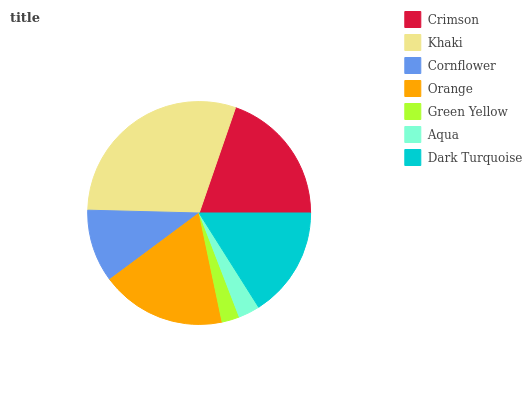Is Green Yellow the minimum?
Answer yes or no. Yes. Is Khaki the maximum?
Answer yes or no. Yes. Is Cornflower the minimum?
Answer yes or no. No. Is Cornflower the maximum?
Answer yes or no. No. Is Khaki greater than Cornflower?
Answer yes or no. Yes. Is Cornflower less than Khaki?
Answer yes or no. Yes. Is Cornflower greater than Khaki?
Answer yes or no. No. Is Khaki less than Cornflower?
Answer yes or no. No. Is Dark Turquoise the high median?
Answer yes or no. Yes. Is Dark Turquoise the low median?
Answer yes or no. Yes. Is Green Yellow the high median?
Answer yes or no. No. Is Aqua the low median?
Answer yes or no. No. 